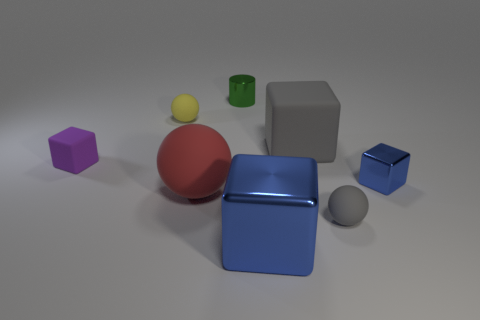Is there a yellow metal thing that has the same size as the purple matte block?
Provide a succinct answer. No. Is the color of the big metallic thing the same as the shiny cube that is to the right of the gray rubber sphere?
Offer a very short reply. Yes. What is the material of the green object?
Your answer should be compact. Metal. There is a small shiny thing that is behind the small yellow matte thing; what color is it?
Make the answer very short. Green. What number of small metal cubes are the same color as the large metallic thing?
Your response must be concise. 1. How many spheres are both right of the big metallic object and behind the gray matte ball?
Keep it short and to the point. 0. What shape is the yellow matte thing that is the same size as the purple object?
Ensure brevity in your answer.  Sphere. The gray rubber block is what size?
Provide a succinct answer. Large. There is a big cube in front of the rubber block to the left of the large matte object in front of the small purple cube; what is its material?
Your response must be concise. Metal. What color is the small sphere that is made of the same material as the tiny yellow thing?
Give a very brief answer. Gray. 